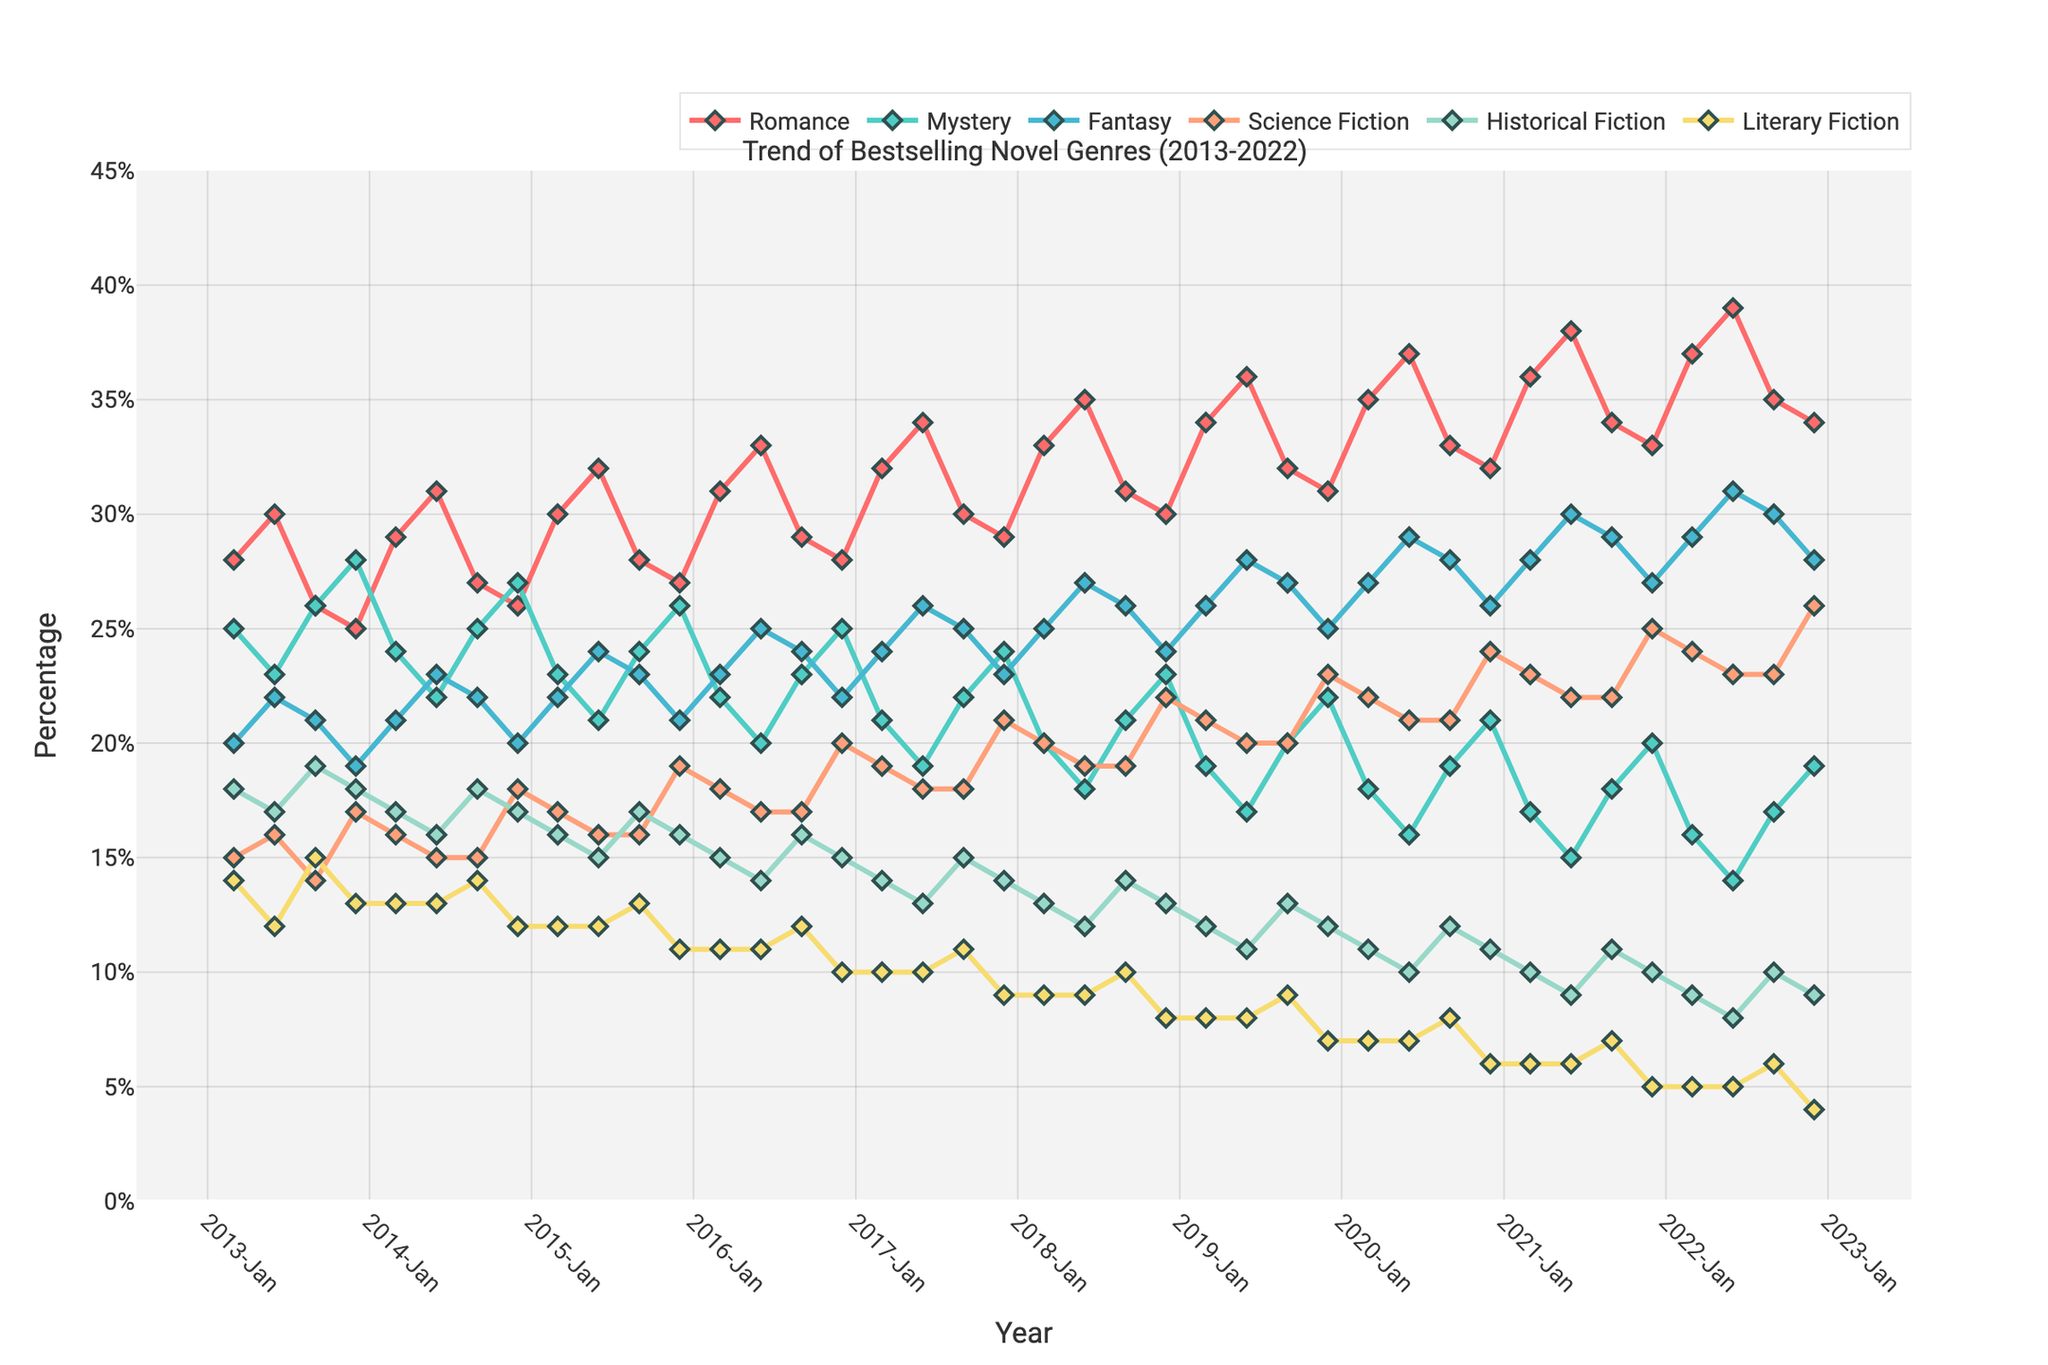What genre had the highest percentage in the Summer of 2022? Looking at the data points for the Summer of 2022, the genre "Romance" reached the highest percentage of 39%.
Answer: Romance Which two genres showed an increasing trend over the entire period from 2013 to 2022? By visually inspecting the lines representing each genre from 2013 to 2022, both "Romance" and "Fantasy" show an overall increasing trend in their percentages.
Answer: Romance, Fantasy During which season did "Historical Fiction" show its lowest percentage, and what was the value? By examining the lowest data point for "Historical Fiction" across all seasons, the lowest value, which is 8%, occurred during Summer 2022.
Answer: Summer 2022, 8% How did the percentage of "Science Fiction" change from Winter 2013 to Winter 2022? In Winter 2013, the percentage of "Science Fiction" was 17%, and for Winter 2022, it was 26%. Therefore, the change is 26% - 17% = 9%.
Answer: Increased by 9% Which genre had the smallest variation in percentage over the entire decade, and what was the range? Observing the data visually, "Literary Fiction" visually appears to have the smallest variation between approximately 14% (at its highest) and 4% (at its lowest), yielding a range of 14% - 4% = 10%.
Answer: Literary Fiction, 10% During which year and season did "Mystery" achieve its highest percentage, and what was the value? Looking at the peaks in the line representing "Mystery", the highest point is during Winter 2013 where it reached 28%.
Answer: Winter 2013, 28% What is the average percentage of "Romance" during the Spring seasons from 2013 to 2022? The Spring percentages for "Romance" from 2013 to 2022 are [28, 29, 30, 31, 32, 33, 34, 35, 36, 37]. Summing these yields 325, and the average is 325/10 = 32.5%.
Answer: 32.5% Compare the overall trend of "Fantasy" and "Science Fiction" from 2013 to 2022. Which one had more fluctuations? Visually comparing the trends, "Science Fiction" has more noticeable peaks and troughs compared to the relatively smoother trend of "Fantasy".
Answer: Science Fiction In which season and year did "Literary Fiction" fall below 10% for the first time? Examining the data points for "Literary Fiction", it fell below 10% for the first time in Winter 2016 at 10%.
Answer: Winter 2016 